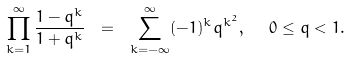<formula> <loc_0><loc_0><loc_500><loc_500>\prod _ { k = 1 } ^ { \infty } \frac { 1 - q ^ { k } } { 1 + q ^ { k } } \ = \ \sum _ { k = - \infty } ^ { \infty } ( - 1 ) ^ { k } q ^ { k ^ { 2 } } , \ \ 0 \leq q < 1 .</formula> 